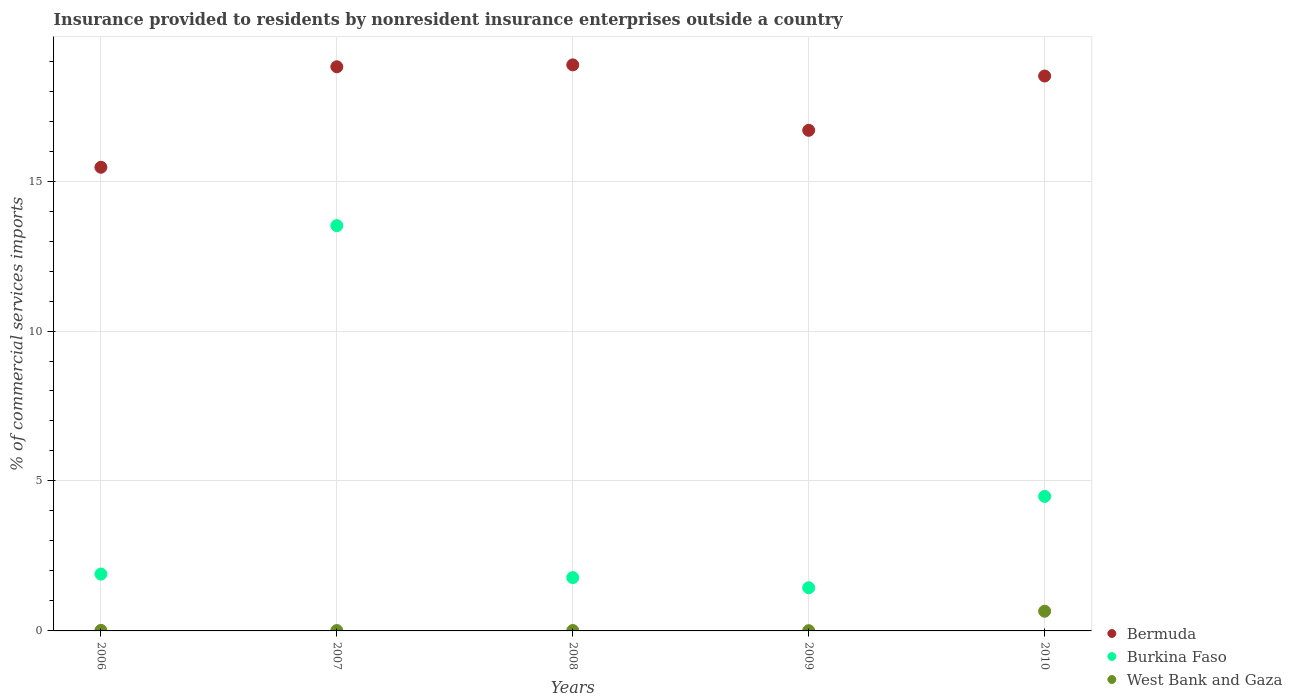How many different coloured dotlines are there?
Offer a very short reply. 3. Is the number of dotlines equal to the number of legend labels?
Keep it short and to the point. Yes. What is the Insurance provided to residents in West Bank and Gaza in 2006?
Keep it short and to the point. 0.02. Across all years, what is the maximum Insurance provided to residents in West Bank and Gaza?
Provide a short and direct response. 0.66. Across all years, what is the minimum Insurance provided to residents in Bermuda?
Make the answer very short. 15.46. In which year was the Insurance provided to residents in Burkina Faso maximum?
Keep it short and to the point. 2007. In which year was the Insurance provided to residents in West Bank and Gaza minimum?
Give a very brief answer. 2009. What is the total Insurance provided to residents in Bermuda in the graph?
Give a very brief answer. 88.34. What is the difference between the Insurance provided to residents in Burkina Faso in 2006 and that in 2007?
Give a very brief answer. -11.62. What is the difference between the Insurance provided to residents in West Bank and Gaza in 2008 and the Insurance provided to residents in Burkina Faso in 2007?
Make the answer very short. -13.5. What is the average Insurance provided to residents in Bermuda per year?
Provide a succinct answer. 17.67. In the year 2008, what is the difference between the Insurance provided to residents in West Bank and Gaza and Insurance provided to residents in Bermuda?
Ensure brevity in your answer.  -18.86. In how many years, is the Insurance provided to residents in West Bank and Gaza greater than 12 %?
Make the answer very short. 0. What is the ratio of the Insurance provided to residents in Bermuda in 2006 to that in 2009?
Offer a terse response. 0.93. Is the difference between the Insurance provided to residents in West Bank and Gaza in 2006 and 2009 greater than the difference between the Insurance provided to residents in Bermuda in 2006 and 2009?
Provide a short and direct response. Yes. What is the difference between the highest and the second highest Insurance provided to residents in Burkina Faso?
Give a very brief answer. 9.03. What is the difference between the highest and the lowest Insurance provided to residents in Burkina Faso?
Provide a succinct answer. 12.07. In how many years, is the Insurance provided to residents in West Bank and Gaza greater than the average Insurance provided to residents in West Bank and Gaza taken over all years?
Offer a terse response. 1. Is the sum of the Insurance provided to residents in Burkina Faso in 2007 and 2008 greater than the maximum Insurance provided to residents in Bermuda across all years?
Give a very brief answer. No. Is it the case that in every year, the sum of the Insurance provided to residents in West Bank and Gaza and Insurance provided to residents in Bermuda  is greater than the Insurance provided to residents in Burkina Faso?
Make the answer very short. Yes. Does the Insurance provided to residents in Burkina Faso monotonically increase over the years?
Your answer should be very brief. No. Is the Insurance provided to residents in West Bank and Gaza strictly less than the Insurance provided to residents in Burkina Faso over the years?
Offer a very short reply. Yes. How many years are there in the graph?
Keep it short and to the point. 5. Are the values on the major ticks of Y-axis written in scientific E-notation?
Give a very brief answer. No. What is the title of the graph?
Keep it short and to the point. Insurance provided to residents by nonresident insurance enterprises outside a country. Does "Belize" appear as one of the legend labels in the graph?
Ensure brevity in your answer.  No. What is the label or title of the Y-axis?
Keep it short and to the point. % of commercial services imports. What is the % of commercial services imports of Bermuda in 2006?
Offer a very short reply. 15.46. What is the % of commercial services imports in Burkina Faso in 2006?
Offer a terse response. 1.9. What is the % of commercial services imports of West Bank and Gaza in 2006?
Provide a succinct answer. 0.02. What is the % of commercial services imports in Bermuda in 2007?
Provide a succinct answer. 18.81. What is the % of commercial services imports of Burkina Faso in 2007?
Ensure brevity in your answer.  13.51. What is the % of commercial services imports in West Bank and Gaza in 2007?
Offer a terse response. 0.01. What is the % of commercial services imports of Bermuda in 2008?
Your answer should be compact. 18.87. What is the % of commercial services imports in Burkina Faso in 2008?
Your answer should be compact. 1.78. What is the % of commercial services imports of West Bank and Gaza in 2008?
Offer a terse response. 0.01. What is the % of commercial services imports of Bermuda in 2009?
Offer a terse response. 16.69. What is the % of commercial services imports in Burkina Faso in 2009?
Keep it short and to the point. 1.44. What is the % of commercial services imports of West Bank and Gaza in 2009?
Your response must be concise. 0.01. What is the % of commercial services imports of Bermuda in 2010?
Offer a very short reply. 18.5. What is the % of commercial services imports in Burkina Faso in 2010?
Offer a very short reply. 4.49. What is the % of commercial services imports in West Bank and Gaza in 2010?
Your answer should be compact. 0.66. Across all years, what is the maximum % of commercial services imports of Bermuda?
Ensure brevity in your answer.  18.87. Across all years, what is the maximum % of commercial services imports of Burkina Faso?
Ensure brevity in your answer.  13.51. Across all years, what is the maximum % of commercial services imports in West Bank and Gaza?
Offer a very short reply. 0.66. Across all years, what is the minimum % of commercial services imports in Bermuda?
Your answer should be very brief. 15.46. Across all years, what is the minimum % of commercial services imports in Burkina Faso?
Your response must be concise. 1.44. Across all years, what is the minimum % of commercial services imports of West Bank and Gaza?
Provide a succinct answer. 0.01. What is the total % of commercial services imports of Bermuda in the graph?
Ensure brevity in your answer.  88.34. What is the total % of commercial services imports of Burkina Faso in the graph?
Provide a succinct answer. 23.11. What is the total % of commercial services imports in West Bank and Gaza in the graph?
Offer a very short reply. 0.71. What is the difference between the % of commercial services imports of Bermuda in 2006 and that in 2007?
Provide a short and direct response. -3.35. What is the difference between the % of commercial services imports in Burkina Faso in 2006 and that in 2007?
Offer a very short reply. -11.62. What is the difference between the % of commercial services imports of West Bank and Gaza in 2006 and that in 2007?
Ensure brevity in your answer.  0.01. What is the difference between the % of commercial services imports in Bermuda in 2006 and that in 2008?
Offer a terse response. -3.41. What is the difference between the % of commercial services imports of Burkina Faso in 2006 and that in 2008?
Give a very brief answer. 0.12. What is the difference between the % of commercial services imports of West Bank and Gaza in 2006 and that in 2008?
Ensure brevity in your answer.  0. What is the difference between the % of commercial services imports in Bermuda in 2006 and that in 2009?
Make the answer very short. -1.23. What is the difference between the % of commercial services imports of Burkina Faso in 2006 and that in 2009?
Ensure brevity in your answer.  0.46. What is the difference between the % of commercial services imports in West Bank and Gaza in 2006 and that in 2009?
Provide a short and direct response. 0.01. What is the difference between the % of commercial services imports in Bermuda in 2006 and that in 2010?
Provide a short and direct response. -3.04. What is the difference between the % of commercial services imports in Burkina Faso in 2006 and that in 2010?
Make the answer very short. -2.59. What is the difference between the % of commercial services imports in West Bank and Gaza in 2006 and that in 2010?
Ensure brevity in your answer.  -0.64. What is the difference between the % of commercial services imports in Bermuda in 2007 and that in 2008?
Your answer should be compact. -0.06. What is the difference between the % of commercial services imports of Burkina Faso in 2007 and that in 2008?
Your answer should be compact. 11.74. What is the difference between the % of commercial services imports in West Bank and Gaza in 2007 and that in 2008?
Provide a succinct answer. -0. What is the difference between the % of commercial services imports of Bermuda in 2007 and that in 2009?
Keep it short and to the point. 2.12. What is the difference between the % of commercial services imports in Burkina Faso in 2007 and that in 2009?
Give a very brief answer. 12.07. What is the difference between the % of commercial services imports in West Bank and Gaza in 2007 and that in 2009?
Keep it short and to the point. 0. What is the difference between the % of commercial services imports in Bermuda in 2007 and that in 2010?
Your answer should be compact. 0.31. What is the difference between the % of commercial services imports in Burkina Faso in 2007 and that in 2010?
Give a very brief answer. 9.03. What is the difference between the % of commercial services imports in West Bank and Gaza in 2007 and that in 2010?
Ensure brevity in your answer.  -0.64. What is the difference between the % of commercial services imports of Bermuda in 2008 and that in 2009?
Provide a succinct answer. 2.18. What is the difference between the % of commercial services imports in Burkina Faso in 2008 and that in 2009?
Offer a terse response. 0.34. What is the difference between the % of commercial services imports in West Bank and Gaza in 2008 and that in 2009?
Your response must be concise. 0.01. What is the difference between the % of commercial services imports of Bermuda in 2008 and that in 2010?
Offer a very short reply. 0.37. What is the difference between the % of commercial services imports of Burkina Faso in 2008 and that in 2010?
Ensure brevity in your answer.  -2.71. What is the difference between the % of commercial services imports in West Bank and Gaza in 2008 and that in 2010?
Provide a succinct answer. -0.64. What is the difference between the % of commercial services imports of Bermuda in 2009 and that in 2010?
Provide a succinct answer. -1.81. What is the difference between the % of commercial services imports of Burkina Faso in 2009 and that in 2010?
Ensure brevity in your answer.  -3.05. What is the difference between the % of commercial services imports in West Bank and Gaza in 2009 and that in 2010?
Provide a succinct answer. -0.65. What is the difference between the % of commercial services imports of Bermuda in 2006 and the % of commercial services imports of Burkina Faso in 2007?
Your answer should be very brief. 1.95. What is the difference between the % of commercial services imports of Bermuda in 2006 and the % of commercial services imports of West Bank and Gaza in 2007?
Ensure brevity in your answer.  15.45. What is the difference between the % of commercial services imports in Burkina Faso in 2006 and the % of commercial services imports in West Bank and Gaza in 2007?
Ensure brevity in your answer.  1.88. What is the difference between the % of commercial services imports in Bermuda in 2006 and the % of commercial services imports in Burkina Faso in 2008?
Offer a terse response. 13.68. What is the difference between the % of commercial services imports of Bermuda in 2006 and the % of commercial services imports of West Bank and Gaza in 2008?
Your response must be concise. 15.45. What is the difference between the % of commercial services imports in Burkina Faso in 2006 and the % of commercial services imports in West Bank and Gaza in 2008?
Provide a short and direct response. 1.88. What is the difference between the % of commercial services imports of Bermuda in 2006 and the % of commercial services imports of Burkina Faso in 2009?
Offer a terse response. 14.02. What is the difference between the % of commercial services imports in Bermuda in 2006 and the % of commercial services imports in West Bank and Gaza in 2009?
Make the answer very short. 15.45. What is the difference between the % of commercial services imports in Burkina Faso in 2006 and the % of commercial services imports in West Bank and Gaza in 2009?
Keep it short and to the point. 1.89. What is the difference between the % of commercial services imports of Bermuda in 2006 and the % of commercial services imports of Burkina Faso in 2010?
Your answer should be very brief. 10.97. What is the difference between the % of commercial services imports in Bermuda in 2006 and the % of commercial services imports in West Bank and Gaza in 2010?
Your answer should be very brief. 14.8. What is the difference between the % of commercial services imports of Burkina Faso in 2006 and the % of commercial services imports of West Bank and Gaza in 2010?
Provide a short and direct response. 1.24. What is the difference between the % of commercial services imports of Bermuda in 2007 and the % of commercial services imports of Burkina Faso in 2008?
Offer a very short reply. 17.03. What is the difference between the % of commercial services imports of Bermuda in 2007 and the % of commercial services imports of West Bank and Gaza in 2008?
Give a very brief answer. 18.8. What is the difference between the % of commercial services imports in Burkina Faso in 2007 and the % of commercial services imports in West Bank and Gaza in 2008?
Ensure brevity in your answer.  13.5. What is the difference between the % of commercial services imports of Bermuda in 2007 and the % of commercial services imports of Burkina Faso in 2009?
Offer a very short reply. 17.37. What is the difference between the % of commercial services imports of Bermuda in 2007 and the % of commercial services imports of West Bank and Gaza in 2009?
Ensure brevity in your answer.  18.8. What is the difference between the % of commercial services imports in Burkina Faso in 2007 and the % of commercial services imports in West Bank and Gaza in 2009?
Make the answer very short. 13.51. What is the difference between the % of commercial services imports in Bermuda in 2007 and the % of commercial services imports in Burkina Faso in 2010?
Make the answer very short. 14.32. What is the difference between the % of commercial services imports in Bermuda in 2007 and the % of commercial services imports in West Bank and Gaza in 2010?
Ensure brevity in your answer.  18.15. What is the difference between the % of commercial services imports of Burkina Faso in 2007 and the % of commercial services imports of West Bank and Gaza in 2010?
Offer a terse response. 12.86. What is the difference between the % of commercial services imports in Bermuda in 2008 and the % of commercial services imports in Burkina Faso in 2009?
Make the answer very short. 17.43. What is the difference between the % of commercial services imports in Bermuda in 2008 and the % of commercial services imports in West Bank and Gaza in 2009?
Your answer should be compact. 18.87. What is the difference between the % of commercial services imports of Burkina Faso in 2008 and the % of commercial services imports of West Bank and Gaza in 2009?
Your answer should be very brief. 1.77. What is the difference between the % of commercial services imports in Bermuda in 2008 and the % of commercial services imports in Burkina Faso in 2010?
Your response must be concise. 14.39. What is the difference between the % of commercial services imports in Bermuda in 2008 and the % of commercial services imports in West Bank and Gaza in 2010?
Your response must be concise. 18.22. What is the difference between the % of commercial services imports of Burkina Faso in 2008 and the % of commercial services imports of West Bank and Gaza in 2010?
Make the answer very short. 1.12. What is the difference between the % of commercial services imports of Bermuda in 2009 and the % of commercial services imports of Burkina Faso in 2010?
Keep it short and to the point. 12.21. What is the difference between the % of commercial services imports in Bermuda in 2009 and the % of commercial services imports in West Bank and Gaza in 2010?
Your answer should be very brief. 16.04. What is the difference between the % of commercial services imports in Burkina Faso in 2009 and the % of commercial services imports in West Bank and Gaza in 2010?
Provide a succinct answer. 0.78. What is the average % of commercial services imports of Bermuda per year?
Make the answer very short. 17.67. What is the average % of commercial services imports in Burkina Faso per year?
Give a very brief answer. 4.62. What is the average % of commercial services imports in West Bank and Gaza per year?
Give a very brief answer. 0.14. In the year 2006, what is the difference between the % of commercial services imports in Bermuda and % of commercial services imports in Burkina Faso?
Keep it short and to the point. 13.56. In the year 2006, what is the difference between the % of commercial services imports in Bermuda and % of commercial services imports in West Bank and Gaza?
Your response must be concise. 15.44. In the year 2006, what is the difference between the % of commercial services imports of Burkina Faso and % of commercial services imports of West Bank and Gaza?
Provide a succinct answer. 1.88. In the year 2007, what is the difference between the % of commercial services imports in Bermuda and % of commercial services imports in Burkina Faso?
Keep it short and to the point. 5.3. In the year 2007, what is the difference between the % of commercial services imports in Bermuda and % of commercial services imports in West Bank and Gaza?
Offer a terse response. 18.8. In the year 2007, what is the difference between the % of commercial services imports in Burkina Faso and % of commercial services imports in West Bank and Gaza?
Your answer should be compact. 13.5. In the year 2008, what is the difference between the % of commercial services imports of Bermuda and % of commercial services imports of Burkina Faso?
Your answer should be very brief. 17.1. In the year 2008, what is the difference between the % of commercial services imports of Bermuda and % of commercial services imports of West Bank and Gaza?
Your answer should be very brief. 18.86. In the year 2008, what is the difference between the % of commercial services imports of Burkina Faso and % of commercial services imports of West Bank and Gaza?
Give a very brief answer. 1.76. In the year 2009, what is the difference between the % of commercial services imports in Bermuda and % of commercial services imports in Burkina Faso?
Your answer should be very brief. 15.25. In the year 2009, what is the difference between the % of commercial services imports of Bermuda and % of commercial services imports of West Bank and Gaza?
Offer a terse response. 16.68. In the year 2009, what is the difference between the % of commercial services imports of Burkina Faso and % of commercial services imports of West Bank and Gaza?
Make the answer very short. 1.43. In the year 2010, what is the difference between the % of commercial services imports of Bermuda and % of commercial services imports of Burkina Faso?
Keep it short and to the point. 14.02. In the year 2010, what is the difference between the % of commercial services imports of Bermuda and % of commercial services imports of West Bank and Gaza?
Ensure brevity in your answer.  17.85. In the year 2010, what is the difference between the % of commercial services imports of Burkina Faso and % of commercial services imports of West Bank and Gaza?
Give a very brief answer. 3.83. What is the ratio of the % of commercial services imports of Bermuda in 2006 to that in 2007?
Your answer should be very brief. 0.82. What is the ratio of the % of commercial services imports of Burkina Faso in 2006 to that in 2007?
Keep it short and to the point. 0.14. What is the ratio of the % of commercial services imports of West Bank and Gaza in 2006 to that in 2007?
Offer a very short reply. 1.51. What is the ratio of the % of commercial services imports of Bermuda in 2006 to that in 2008?
Provide a short and direct response. 0.82. What is the ratio of the % of commercial services imports in Burkina Faso in 2006 to that in 2008?
Offer a terse response. 1.07. What is the ratio of the % of commercial services imports of West Bank and Gaza in 2006 to that in 2008?
Your answer should be compact. 1.33. What is the ratio of the % of commercial services imports of Bermuda in 2006 to that in 2009?
Provide a short and direct response. 0.93. What is the ratio of the % of commercial services imports of Burkina Faso in 2006 to that in 2009?
Provide a succinct answer. 1.32. What is the ratio of the % of commercial services imports in West Bank and Gaza in 2006 to that in 2009?
Offer a very short reply. 2.28. What is the ratio of the % of commercial services imports of Bermuda in 2006 to that in 2010?
Give a very brief answer. 0.84. What is the ratio of the % of commercial services imports in Burkina Faso in 2006 to that in 2010?
Your answer should be compact. 0.42. What is the ratio of the % of commercial services imports in West Bank and Gaza in 2006 to that in 2010?
Provide a succinct answer. 0.03. What is the ratio of the % of commercial services imports in Burkina Faso in 2007 to that in 2008?
Make the answer very short. 7.6. What is the ratio of the % of commercial services imports in West Bank and Gaza in 2007 to that in 2008?
Provide a succinct answer. 0.88. What is the ratio of the % of commercial services imports of Bermuda in 2007 to that in 2009?
Offer a very short reply. 1.13. What is the ratio of the % of commercial services imports in Burkina Faso in 2007 to that in 2009?
Offer a terse response. 9.39. What is the ratio of the % of commercial services imports in West Bank and Gaza in 2007 to that in 2009?
Your answer should be compact. 1.5. What is the ratio of the % of commercial services imports in Bermuda in 2007 to that in 2010?
Provide a succinct answer. 1.02. What is the ratio of the % of commercial services imports of Burkina Faso in 2007 to that in 2010?
Provide a succinct answer. 3.01. What is the ratio of the % of commercial services imports of West Bank and Gaza in 2007 to that in 2010?
Ensure brevity in your answer.  0.02. What is the ratio of the % of commercial services imports of Bermuda in 2008 to that in 2009?
Offer a very short reply. 1.13. What is the ratio of the % of commercial services imports of Burkina Faso in 2008 to that in 2009?
Make the answer very short. 1.24. What is the ratio of the % of commercial services imports in West Bank and Gaza in 2008 to that in 2009?
Keep it short and to the point. 1.71. What is the ratio of the % of commercial services imports in Bermuda in 2008 to that in 2010?
Make the answer very short. 1.02. What is the ratio of the % of commercial services imports in Burkina Faso in 2008 to that in 2010?
Make the answer very short. 0.4. What is the ratio of the % of commercial services imports in West Bank and Gaza in 2008 to that in 2010?
Ensure brevity in your answer.  0.02. What is the ratio of the % of commercial services imports in Bermuda in 2009 to that in 2010?
Offer a very short reply. 0.9. What is the ratio of the % of commercial services imports of Burkina Faso in 2009 to that in 2010?
Your response must be concise. 0.32. What is the ratio of the % of commercial services imports of West Bank and Gaza in 2009 to that in 2010?
Keep it short and to the point. 0.01. What is the difference between the highest and the second highest % of commercial services imports in Bermuda?
Offer a terse response. 0.06. What is the difference between the highest and the second highest % of commercial services imports in Burkina Faso?
Provide a succinct answer. 9.03. What is the difference between the highest and the second highest % of commercial services imports in West Bank and Gaza?
Your response must be concise. 0.64. What is the difference between the highest and the lowest % of commercial services imports of Bermuda?
Provide a short and direct response. 3.41. What is the difference between the highest and the lowest % of commercial services imports in Burkina Faso?
Keep it short and to the point. 12.07. What is the difference between the highest and the lowest % of commercial services imports of West Bank and Gaza?
Make the answer very short. 0.65. 